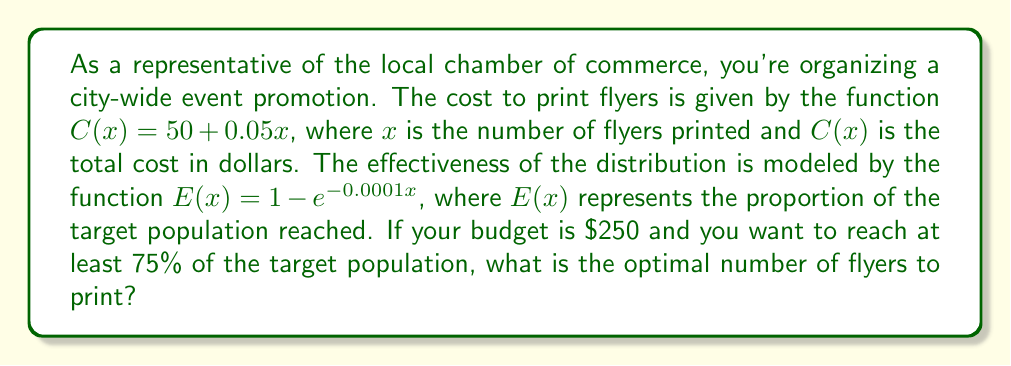Teach me how to tackle this problem. To solve this problem, we need to follow these steps:

1. Find the maximum number of flyers that can be printed within the budget.
2. Find the minimum number of flyers needed to reach 75% of the target population.
3. Choose the smaller of these two numbers as the optimal number of flyers.

Step 1: Maximum number of flyers within budget
The cost function is $C(x) = 50 + 0.05x$
Set this equal to the budget and solve for x:
$$250 = 50 + 0.05x$$
$$200 = 0.05x$$
$$x = 4000$$

Step 2: Minimum number of flyers to reach 75% of the population
The effectiveness function is $E(x) = 1 - e^{-0.0001x}$
Set this equal to 0.75 and solve for x:
$$0.75 = 1 - e^{-0.0001x}$$
$$0.25 = e^{-0.0001x}$$
$$\ln(0.25) = -0.0001x$$
$$x = \frac{\ln(0.25)}{-0.0001} \approx 13863$$

Step 3: Choose the smaller number
The budget constraint (4000 flyers) is smaller than the effectiveness constraint (13863 flyers), so the optimal number of flyers to print is 4000.
Answer: The optimal number of flyers to print is 4000. 